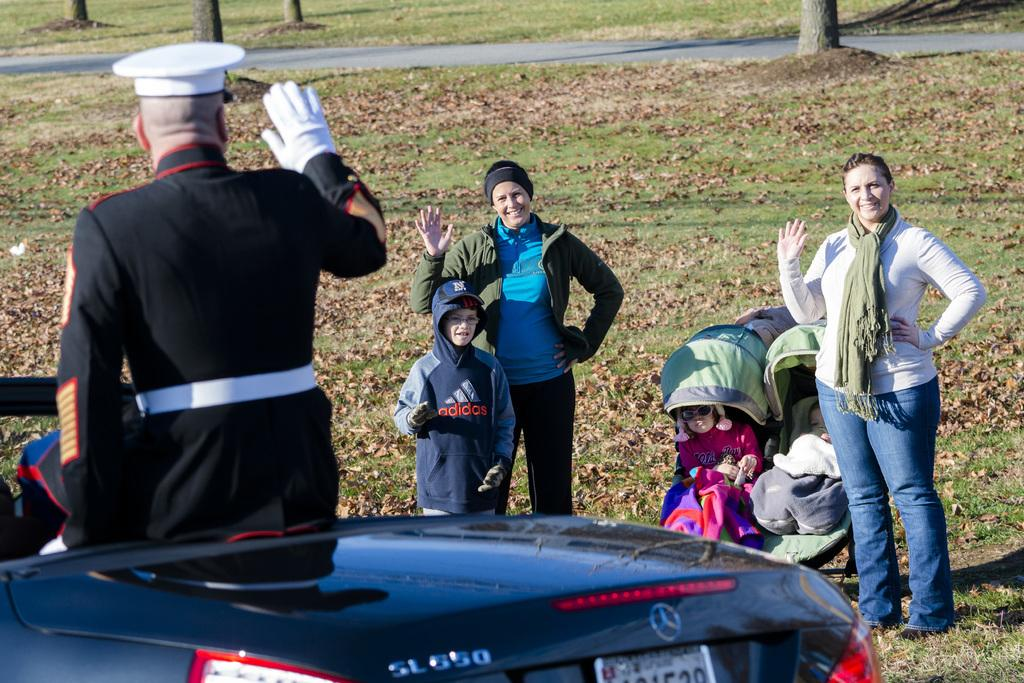What type of vegetation is visible in the image? There is grass in the image. What type of vehicle is present in the image? There is a car in the image. Are there any living beings in the image? Yes, there are people in the image. What type of toy can be seen on the nerve plate in the image? There is no toy or nerve plate present in the image. What type of plate is used to serve the grass in the image? There is no plate present in the image, as the grass is growing naturally. 